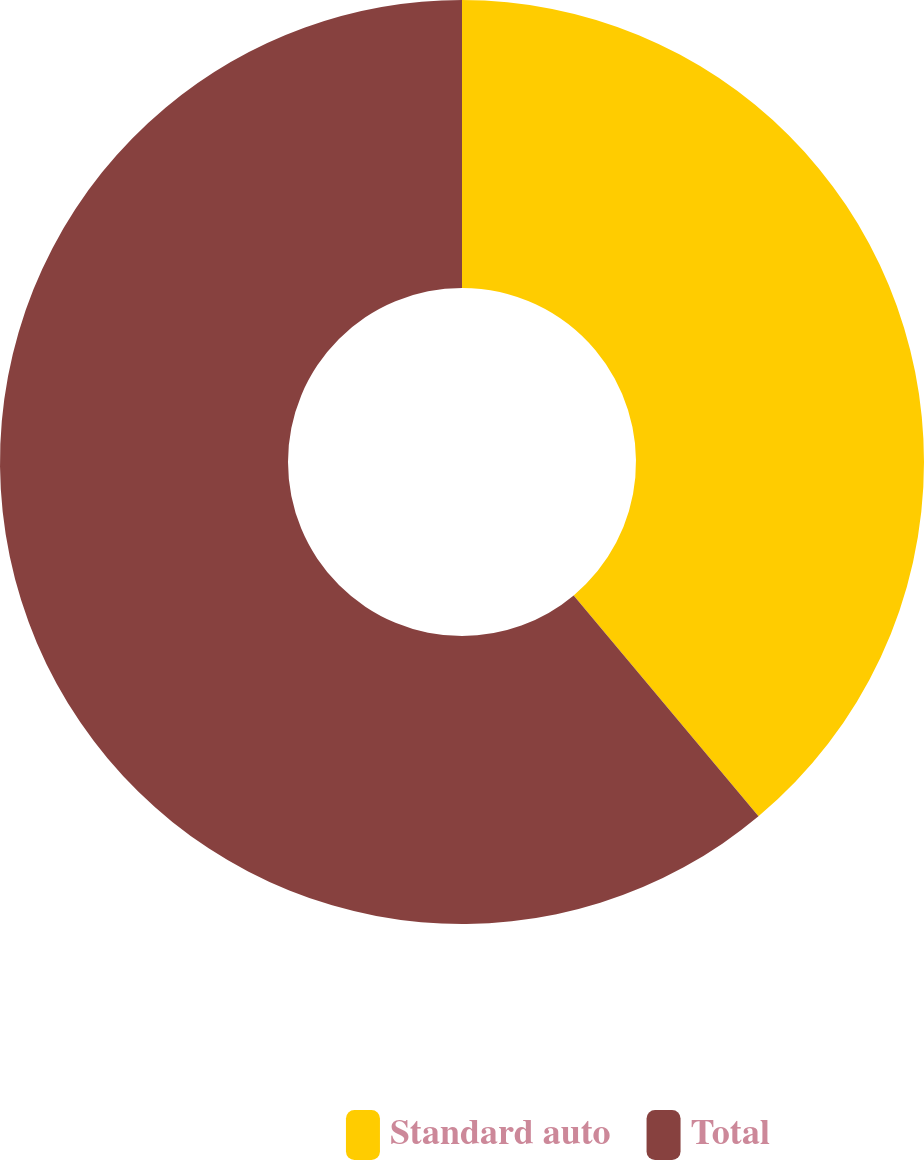Convert chart to OTSL. <chart><loc_0><loc_0><loc_500><loc_500><pie_chart><fcel>Standard auto<fcel>Total<nl><fcel>38.91%<fcel>61.09%<nl></chart> 